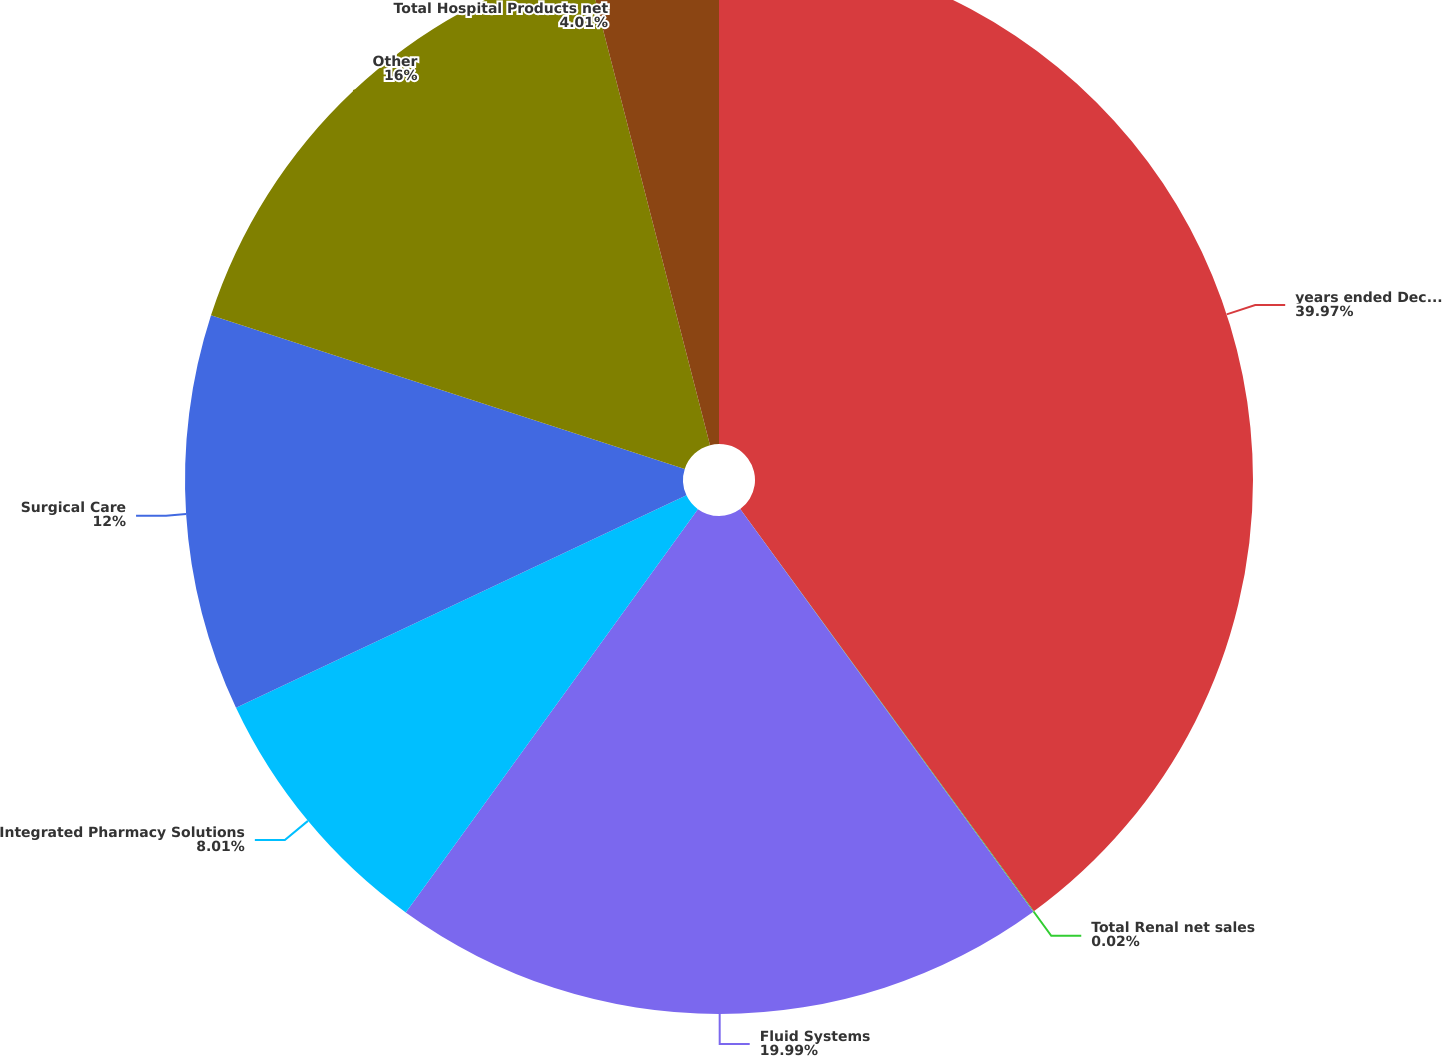Convert chart to OTSL. <chart><loc_0><loc_0><loc_500><loc_500><pie_chart><fcel>years ended December 31 (in<fcel>Total Renal net sales<fcel>Fluid Systems<fcel>Integrated Pharmacy Solutions<fcel>Surgical Care<fcel>Other<fcel>Total Hospital Products net<nl><fcel>39.96%<fcel>0.02%<fcel>19.99%<fcel>8.01%<fcel>12.0%<fcel>16.0%<fcel>4.01%<nl></chart> 